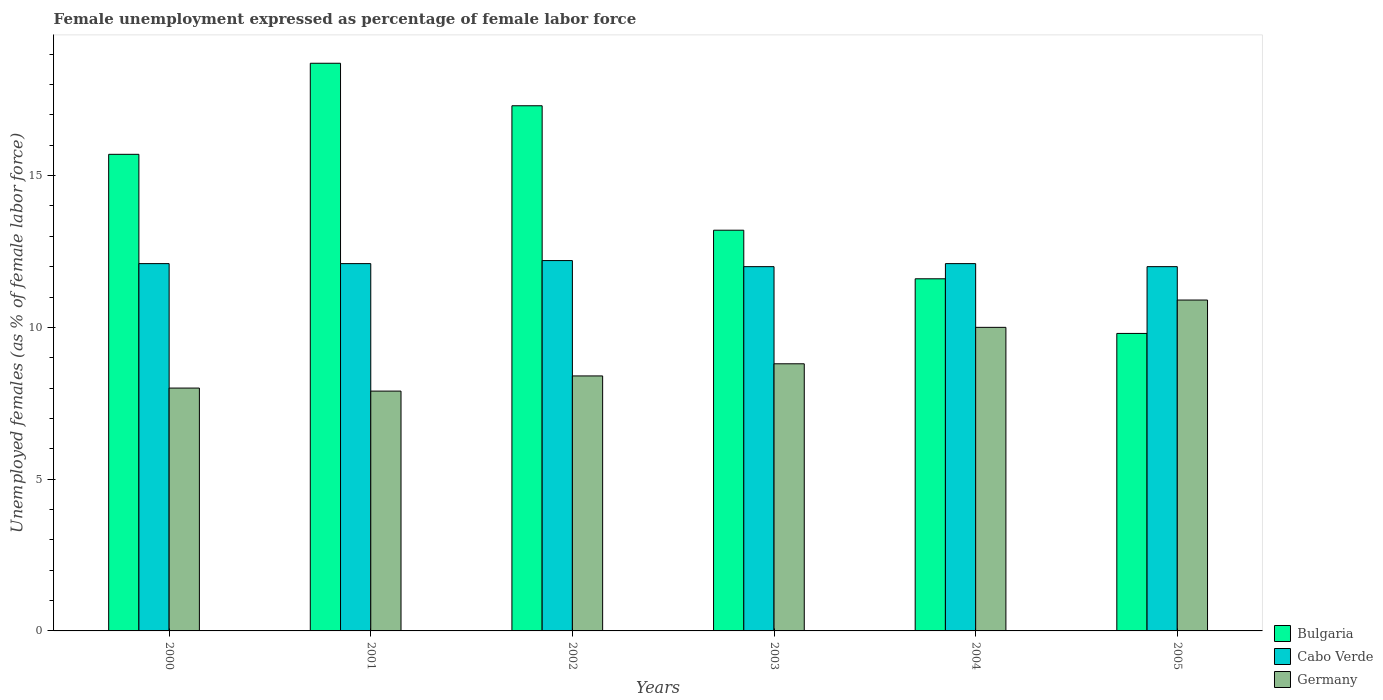How many groups of bars are there?
Provide a short and direct response. 6. How many bars are there on the 6th tick from the left?
Ensure brevity in your answer.  3. How many bars are there on the 6th tick from the right?
Provide a succinct answer. 3. What is the label of the 4th group of bars from the left?
Your answer should be very brief. 2003. In how many cases, is the number of bars for a given year not equal to the number of legend labels?
Your answer should be very brief. 0. What is the unemployment in females in in Germany in 2003?
Offer a terse response. 8.8. Across all years, what is the maximum unemployment in females in in Germany?
Your response must be concise. 10.9. Across all years, what is the minimum unemployment in females in in Germany?
Provide a succinct answer. 7.9. In which year was the unemployment in females in in Cabo Verde minimum?
Provide a short and direct response. 2003. What is the total unemployment in females in in Bulgaria in the graph?
Offer a terse response. 86.3. What is the difference between the unemployment in females in in Germany in 2001 and that in 2003?
Offer a terse response. -0.9. What is the difference between the unemployment in females in in Cabo Verde in 2005 and the unemployment in females in in Germany in 2001?
Make the answer very short. 4.1. What is the average unemployment in females in in Germany per year?
Offer a very short reply. 9. In the year 2002, what is the difference between the unemployment in females in in Cabo Verde and unemployment in females in in Germany?
Your answer should be compact. 3.8. In how many years, is the unemployment in females in in Bulgaria greater than 13 %?
Offer a very short reply. 4. What is the ratio of the unemployment in females in in Cabo Verde in 2001 to that in 2003?
Make the answer very short. 1.01. Is the unemployment in females in in Germany in 2001 less than that in 2002?
Provide a short and direct response. Yes. What is the difference between the highest and the second highest unemployment in females in in Cabo Verde?
Offer a very short reply. 0.1. What is the difference between the highest and the lowest unemployment in females in in Germany?
Provide a short and direct response. 3. In how many years, is the unemployment in females in in Cabo Verde greater than the average unemployment in females in in Cabo Verde taken over all years?
Offer a very short reply. 4. What does the 2nd bar from the left in 2002 represents?
Provide a succinct answer. Cabo Verde. What does the 2nd bar from the right in 2001 represents?
Your answer should be compact. Cabo Verde. How many bars are there?
Provide a short and direct response. 18. How many years are there in the graph?
Your response must be concise. 6. Are the values on the major ticks of Y-axis written in scientific E-notation?
Offer a terse response. No. Does the graph contain any zero values?
Offer a terse response. No. Where does the legend appear in the graph?
Your response must be concise. Bottom right. How many legend labels are there?
Your answer should be very brief. 3. How are the legend labels stacked?
Offer a very short reply. Vertical. What is the title of the graph?
Give a very brief answer. Female unemployment expressed as percentage of female labor force. What is the label or title of the Y-axis?
Ensure brevity in your answer.  Unemployed females (as % of female labor force). What is the Unemployed females (as % of female labor force) in Bulgaria in 2000?
Your answer should be very brief. 15.7. What is the Unemployed females (as % of female labor force) in Cabo Verde in 2000?
Your response must be concise. 12.1. What is the Unemployed females (as % of female labor force) in Germany in 2000?
Your answer should be compact. 8. What is the Unemployed females (as % of female labor force) in Bulgaria in 2001?
Your answer should be very brief. 18.7. What is the Unemployed females (as % of female labor force) in Cabo Verde in 2001?
Your answer should be very brief. 12.1. What is the Unemployed females (as % of female labor force) in Germany in 2001?
Your response must be concise. 7.9. What is the Unemployed females (as % of female labor force) in Bulgaria in 2002?
Give a very brief answer. 17.3. What is the Unemployed females (as % of female labor force) in Cabo Verde in 2002?
Your answer should be very brief. 12.2. What is the Unemployed females (as % of female labor force) in Germany in 2002?
Give a very brief answer. 8.4. What is the Unemployed females (as % of female labor force) of Bulgaria in 2003?
Offer a very short reply. 13.2. What is the Unemployed females (as % of female labor force) of Germany in 2003?
Give a very brief answer. 8.8. What is the Unemployed females (as % of female labor force) in Bulgaria in 2004?
Give a very brief answer. 11.6. What is the Unemployed females (as % of female labor force) of Cabo Verde in 2004?
Make the answer very short. 12.1. What is the Unemployed females (as % of female labor force) in Germany in 2004?
Give a very brief answer. 10. What is the Unemployed females (as % of female labor force) of Bulgaria in 2005?
Keep it short and to the point. 9.8. What is the Unemployed females (as % of female labor force) in Cabo Verde in 2005?
Offer a terse response. 12. What is the Unemployed females (as % of female labor force) of Germany in 2005?
Your answer should be compact. 10.9. Across all years, what is the maximum Unemployed females (as % of female labor force) in Bulgaria?
Your response must be concise. 18.7. Across all years, what is the maximum Unemployed females (as % of female labor force) of Cabo Verde?
Your response must be concise. 12.2. Across all years, what is the maximum Unemployed females (as % of female labor force) in Germany?
Offer a very short reply. 10.9. Across all years, what is the minimum Unemployed females (as % of female labor force) of Bulgaria?
Offer a very short reply. 9.8. Across all years, what is the minimum Unemployed females (as % of female labor force) in Cabo Verde?
Keep it short and to the point. 12. Across all years, what is the minimum Unemployed females (as % of female labor force) of Germany?
Ensure brevity in your answer.  7.9. What is the total Unemployed females (as % of female labor force) of Bulgaria in the graph?
Offer a very short reply. 86.3. What is the total Unemployed females (as % of female labor force) of Cabo Verde in the graph?
Your answer should be very brief. 72.5. What is the difference between the Unemployed females (as % of female labor force) in Bulgaria in 2000 and that in 2001?
Give a very brief answer. -3. What is the difference between the Unemployed females (as % of female labor force) of Germany in 2000 and that in 2001?
Provide a short and direct response. 0.1. What is the difference between the Unemployed females (as % of female labor force) in Cabo Verde in 2000 and that in 2002?
Make the answer very short. -0.1. What is the difference between the Unemployed females (as % of female labor force) in Germany in 2000 and that in 2002?
Give a very brief answer. -0.4. What is the difference between the Unemployed females (as % of female labor force) of Bulgaria in 2000 and that in 2003?
Offer a very short reply. 2.5. What is the difference between the Unemployed females (as % of female labor force) of Cabo Verde in 2000 and that in 2003?
Make the answer very short. 0.1. What is the difference between the Unemployed females (as % of female labor force) of Germany in 2000 and that in 2003?
Offer a terse response. -0.8. What is the difference between the Unemployed females (as % of female labor force) of Cabo Verde in 2000 and that in 2004?
Give a very brief answer. 0. What is the difference between the Unemployed females (as % of female labor force) of Germany in 2000 and that in 2004?
Your answer should be compact. -2. What is the difference between the Unemployed females (as % of female labor force) of Bulgaria in 2000 and that in 2005?
Ensure brevity in your answer.  5.9. What is the difference between the Unemployed females (as % of female labor force) in Cabo Verde in 2000 and that in 2005?
Your response must be concise. 0.1. What is the difference between the Unemployed females (as % of female labor force) in Germany in 2000 and that in 2005?
Your response must be concise. -2.9. What is the difference between the Unemployed females (as % of female labor force) in Bulgaria in 2001 and that in 2002?
Make the answer very short. 1.4. What is the difference between the Unemployed females (as % of female labor force) of Germany in 2001 and that in 2002?
Provide a succinct answer. -0.5. What is the difference between the Unemployed females (as % of female labor force) in Cabo Verde in 2001 and that in 2004?
Keep it short and to the point. 0. What is the difference between the Unemployed females (as % of female labor force) in Germany in 2001 and that in 2004?
Provide a short and direct response. -2.1. What is the difference between the Unemployed females (as % of female labor force) of Bulgaria in 2001 and that in 2005?
Keep it short and to the point. 8.9. What is the difference between the Unemployed females (as % of female labor force) in Bulgaria in 2002 and that in 2003?
Keep it short and to the point. 4.1. What is the difference between the Unemployed females (as % of female labor force) in Bulgaria in 2002 and that in 2005?
Offer a terse response. 7.5. What is the difference between the Unemployed females (as % of female labor force) of Germany in 2002 and that in 2005?
Your answer should be very brief. -2.5. What is the difference between the Unemployed females (as % of female labor force) in Germany in 2003 and that in 2004?
Provide a succinct answer. -1.2. What is the difference between the Unemployed females (as % of female labor force) of Bulgaria in 2003 and that in 2005?
Give a very brief answer. 3.4. What is the difference between the Unemployed females (as % of female labor force) of Germany in 2003 and that in 2005?
Keep it short and to the point. -2.1. What is the difference between the Unemployed females (as % of female labor force) of Bulgaria in 2004 and that in 2005?
Provide a succinct answer. 1.8. What is the difference between the Unemployed females (as % of female labor force) in Cabo Verde in 2004 and that in 2005?
Provide a short and direct response. 0.1. What is the difference between the Unemployed females (as % of female labor force) of Cabo Verde in 2000 and the Unemployed females (as % of female labor force) of Germany in 2001?
Your response must be concise. 4.2. What is the difference between the Unemployed females (as % of female labor force) of Bulgaria in 2000 and the Unemployed females (as % of female labor force) of Cabo Verde in 2002?
Offer a terse response. 3.5. What is the difference between the Unemployed females (as % of female labor force) of Bulgaria in 2000 and the Unemployed females (as % of female labor force) of Germany in 2002?
Offer a terse response. 7.3. What is the difference between the Unemployed females (as % of female labor force) in Cabo Verde in 2000 and the Unemployed females (as % of female labor force) in Germany in 2002?
Make the answer very short. 3.7. What is the difference between the Unemployed females (as % of female labor force) in Bulgaria in 2000 and the Unemployed females (as % of female labor force) in Cabo Verde in 2003?
Provide a short and direct response. 3.7. What is the difference between the Unemployed females (as % of female labor force) in Cabo Verde in 2000 and the Unemployed females (as % of female labor force) in Germany in 2003?
Provide a succinct answer. 3.3. What is the difference between the Unemployed females (as % of female labor force) of Bulgaria in 2000 and the Unemployed females (as % of female labor force) of Cabo Verde in 2004?
Make the answer very short. 3.6. What is the difference between the Unemployed females (as % of female labor force) of Bulgaria in 2000 and the Unemployed females (as % of female labor force) of Germany in 2005?
Your answer should be compact. 4.8. What is the difference between the Unemployed females (as % of female labor force) in Cabo Verde in 2000 and the Unemployed females (as % of female labor force) in Germany in 2005?
Provide a short and direct response. 1.2. What is the difference between the Unemployed females (as % of female labor force) of Bulgaria in 2001 and the Unemployed females (as % of female labor force) of Germany in 2002?
Your response must be concise. 10.3. What is the difference between the Unemployed females (as % of female labor force) in Bulgaria in 2001 and the Unemployed females (as % of female labor force) in Germany in 2003?
Your answer should be compact. 9.9. What is the difference between the Unemployed females (as % of female labor force) in Bulgaria in 2001 and the Unemployed females (as % of female labor force) in Germany in 2004?
Ensure brevity in your answer.  8.7. What is the difference between the Unemployed females (as % of female labor force) of Bulgaria in 2001 and the Unemployed females (as % of female labor force) of Cabo Verde in 2005?
Provide a succinct answer. 6.7. What is the difference between the Unemployed females (as % of female labor force) of Cabo Verde in 2001 and the Unemployed females (as % of female labor force) of Germany in 2005?
Ensure brevity in your answer.  1.2. What is the difference between the Unemployed females (as % of female labor force) in Bulgaria in 2002 and the Unemployed females (as % of female labor force) in Cabo Verde in 2003?
Your response must be concise. 5.3. What is the difference between the Unemployed females (as % of female labor force) in Cabo Verde in 2002 and the Unemployed females (as % of female labor force) in Germany in 2003?
Provide a short and direct response. 3.4. What is the difference between the Unemployed females (as % of female labor force) of Cabo Verde in 2002 and the Unemployed females (as % of female labor force) of Germany in 2004?
Offer a very short reply. 2.2. What is the difference between the Unemployed females (as % of female labor force) in Bulgaria in 2002 and the Unemployed females (as % of female labor force) in Cabo Verde in 2005?
Your response must be concise. 5.3. What is the difference between the Unemployed females (as % of female labor force) in Bulgaria in 2002 and the Unemployed females (as % of female labor force) in Germany in 2005?
Your answer should be very brief. 6.4. What is the difference between the Unemployed females (as % of female labor force) in Bulgaria in 2003 and the Unemployed females (as % of female labor force) in Germany in 2004?
Provide a succinct answer. 3.2. What is the difference between the Unemployed females (as % of female labor force) of Bulgaria in 2004 and the Unemployed females (as % of female labor force) of Germany in 2005?
Offer a very short reply. 0.7. What is the average Unemployed females (as % of female labor force) in Bulgaria per year?
Ensure brevity in your answer.  14.38. What is the average Unemployed females (as % of female labor force) in Cabo Verde per year?
Your answer should be very brief. 12.08. In the year 2000, what is the difference between the Unemployed females (as % of female labor force) in Bulgaria and Unemployed females (as % of female labor force) in Cabo Verde?
Keep it short and to the point. 3.6. In the year 2001, what is the difference between the Unemployed females (as % of female labor force) in Bulgaria and Unemployed females (as % of female labor force) in Germany?
Provide a short and direct response. 10.8. In the year 2001, what is the difference between the Unemployed females (as % of female labor force) of Cabo Verde and Unemployed females (as % of female labor force) of Germany?
Your answer should be very brief. 4.2. In the year 2002, what is the difference between the Unemployed females (as % of female labor force) of Bulgaria and Unemployed females (as % of female labor force) of Germany?
Provide a succinct answer. 8.9. In the year 2002, what is the difference between the Unemployed females (as % of female labor force) in Cabo Verde and Unemployed females (as % of female labor force) in Germany?
Your answer should be compact. 3.8. In the year 2003, what is the difference between the Unemployed females (as % of female labor force) in Cabo Verde and Unemployed females (as % of female labor force) in Germany?
Keep it short and to the point. 3.2. In the year 2004, what is the difference between the Unemployed females (as % of female labor force) in Bulgaria and Unemployed females (as % of female labor force) in Cabo Verde?
Offer a terse response. -0.5. In the year 2005, what is the difference between the Unemployed females (as % of female labor force) in Bulgaria and Unemployed females (as % of female labor force) in Germany?
Your answer should be compact. -1.1. In the year 2005, what is the difference between the Unemployed females (as % of female labor force) of Cabo Verde and Unemployed females (as % of female labor force) of Germany?
Make the answer very short. 1.1. What is the ratio of the Unemployed females (as % of female labor force) of Bulgaria in 2000 to that in 2001?
Give a very brief answer. 0.84. What is the ratio of the Unemployed females (as % of female labor force) of Germany in 2000 to that in 2001?
Provide a short and direct response. 1.01. What is the ratio of the Unemployed females (as % of female labor force) of Bulgaria in 2000 to that in 2002?
Make the answer very short. 0.91. What is the ratio of the Unemployed females (as % of female labor force) of Bulgaria in 2000 to that in 2003?
Give a very brief answer. 1.19. What is the ratio of the Unemployed females (as % of female labor force) in Cabo Verde in 2000 to that in 2003?
Your response must be concise. 1.01. What is the ratio of the Unemployed females (as % of female labor force) of Germany in 2000 to that in 2003?
Give a very brief answer. 0.91. What is the ratio of the Unemployed females (as % of female labor force) in Bulgaria in 2000 to that in 2004?
Your answer should be compact. 1.35. What is the ratio of the Unemployed females (as % of female labor force) of Germany in 2000 to that in 2004?
Keep it short and to the point. 0.8. What is the ratio of the Unemployed females (as % of female labor force) in Bulgaria in 2000 to that in 2005?
Offer a very short reply. 1.6. What is the ratio of the Unemployed females (as % of female labor force) in Cabo Verde in 2000 to that in 2005?
Provide a succinct answer. 1.01. What is the ratio of the Unemployed females (as % of female labor force) in Germany in 2000 to that in 2005?
Give a very brief answer. 0.73. What is the ratio of the Unemployed females (as % of female labor force) in Bulgaria in 2001 to that in 2002?
Keep it short and to the point. 1.08. What is the ratio of the Unemployed females (as % of female labor force) of Cabo Verde in 2001 to that in 2002?
Keep it short and to the point. 0.99. What is the ratio of the Unemployed females (as % of female labor force) in Germany in 2001 to that in 2002?
Provide a succinct answer. 0.94. What is the ratio of the Unemployed females (as % of female labor force) of Bulgaria in 2001 to that in 2003?
Offer a terse response. 1.42. What is the ratio of the Unemployed females (as % of female labor force) in Cabo Verde in 2001 to that in 2003?
Your answer should be compact. 1.01. What is the ratio of the Unemployed females (as % of female labor force) of Germany in 2001 to that in 2003?
Provide a succinct answer. 0.9. What is the ratio of the Unemployed females (as % of female labor force) in Bulgaria in 2001 to that in 2004?
Provide a succinct answer. 1.61. What is the ratio of the Unemployed females (as % of female labor force) in Cabo Verde in 2001 to that in 2004?
Offer a terse response. 1. What is the ratio of the Unemployed females (as % of female labor force) of Germany in 2001 to that in 2004?
Your response must be concise. 0.79. What is the ratio of the Unemployed females (as % of female labor force) of Bulgaria in 2001 to that in 2005?
Keep it short and to the point. 1.91. What is the ratio of the Unemployed females (as % of female labor force) of Cabo Verde in 2001 to that in 2005?
Your answer should be very brief. 1.01. What is the ratio of the Unemployed females (as % of female labor force) of Germany in 2001 to that in 2005?
Offer a very short reply. 0.72. What is the ratio of the Unemployed females (as % of female labor force) in Bulgaria in 2002 to that in 2003?
Your answer should be very brief. 1.31. What is the ratio of the Unemployed females (as % of female labor force) of Cabo Verde in 2002 to that in 2003?
Your response must be concise. 1.02. What is the ratio of the Unemployed females (as % of female labor force) of Germany in 2002 to that in 2003?
Provide a succinct answer. 0.95. What is the ratio of the Unemployed females (as % of female labor force) in Bulgaria in 2002 to that in 2004?
Ensure brevity in your answer.  1.49. What is the ratio of the Unemployed females (as % of female labor force) of Cabo Verde in 2002 to that in 2004?
Make the answer very short. 1.01. What is the ratio of the Unemployed females (as % of female labor force) in Germany in 2002 to that in 2004?
Your response must be concise. 0.84. What is the ratio of the Unemployed females (as % of female labor force) of Bulgaria in 2002 to that in 2005?
Provide a short and direct response. 1.77. What is the ratio of the Unemployed females (as % of female labor force) of Cabo Verde in 2002 to that in 2005?
Your response must be concise. 1.02. What is the ratio of the Unemployed females (as % of female labor force) of Germany in 2002 to that in 2005?
Offer a terse response. 0.77. What is the ratio of the Unemployed females (as % of female labor force) of Bulgaria in 2003 to that in 2004?
Your answer should be compact. 1.14. What is the ratio of the Unemployed females (as % of female labor force) in Bulgaria in 2003 to that in 2005?
Your answer should be compact. 1.35. What is the ratio of the Unemployed females (as % of female labor force) in Cabo Verde in 2003 to that in 2005?
Your answer should be very brief. 1. What is the ratio of the Unemployed females (as % of female labor force) in Germany in 2003 to that in 2005?
Offer a very short reply. 0.81. What is the ratio of the Unemployed females (as % of female labor force) of Bulgaria in 2004 to that in 2005?
Offer a terse response. 1.18. What is the ratio of the Unemployed females (as % of female labor force) in Cabo Verde in 2004 to that in 2005?
Your response must be concise. 1.01. What is the ratio of the Unemployed females (as % of female labor force) of Germany in 2004 to that in 2005?
Provide a succinct answer. 0.92. What is the difference between the highest and the second highest Unemployed females (as % of female labor force) in Bulgaria?
Offer a terse response. 1.4. What is the difference between the highest and the lowest Unemployed females (as % of female labor force) of Bulgaria?
Your response must be concise. 8.9. What is the difference between the highest and the lowest Unemployed females (as % of female labor force) of Cabo Verde?
Your response must be concise. 0.2. What is the difference between the highest and the lowest Unemployed females (as % of female labor force) of Germany?
Your answer should be very brief. 3. 